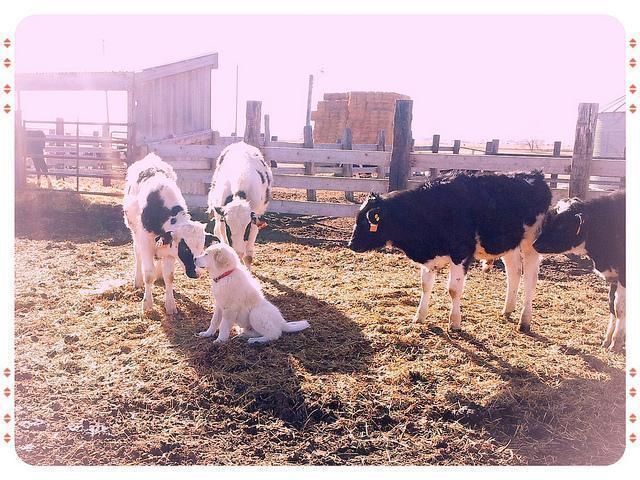What are the cows looking at?
Indicate the correct response by choosing from the four available options to answer the question.
Options: Dog, rat, lion, cat. Dog. 